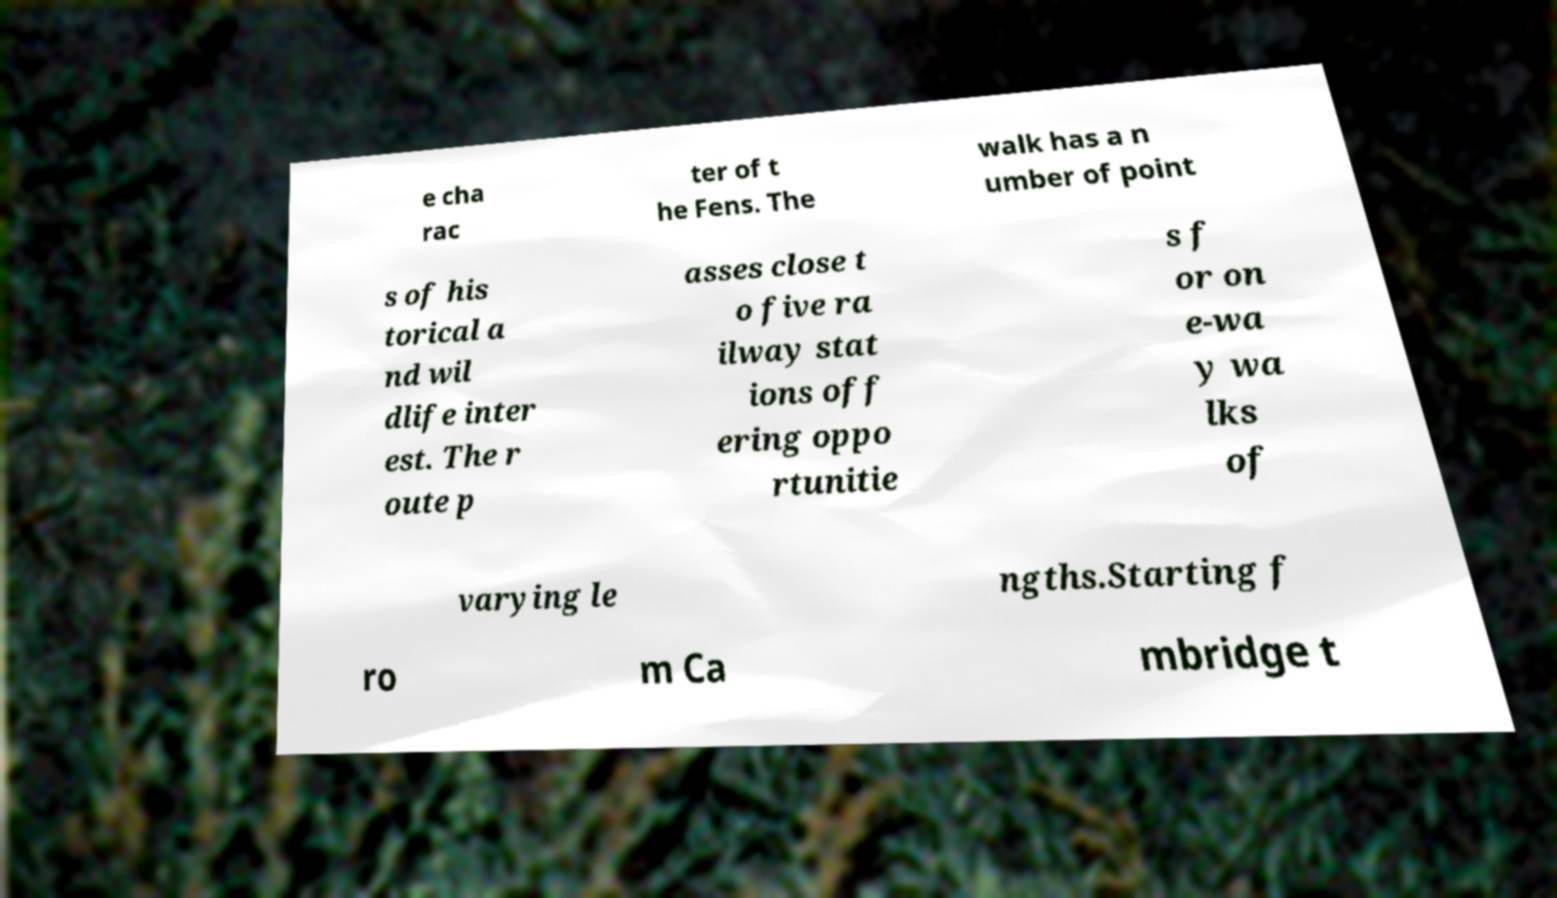Could you extract and type out the text from this image? e cha rac ter of t he Fens. The walk has a n umber of point s of his torical a nd wil dlife inter est. The r oute p asses close t o five ra ilway stat ions off ering oppo rtunitie s f or on e-wa y wa lks of varying le ngths.Starting f ro m Ca mbridge t 